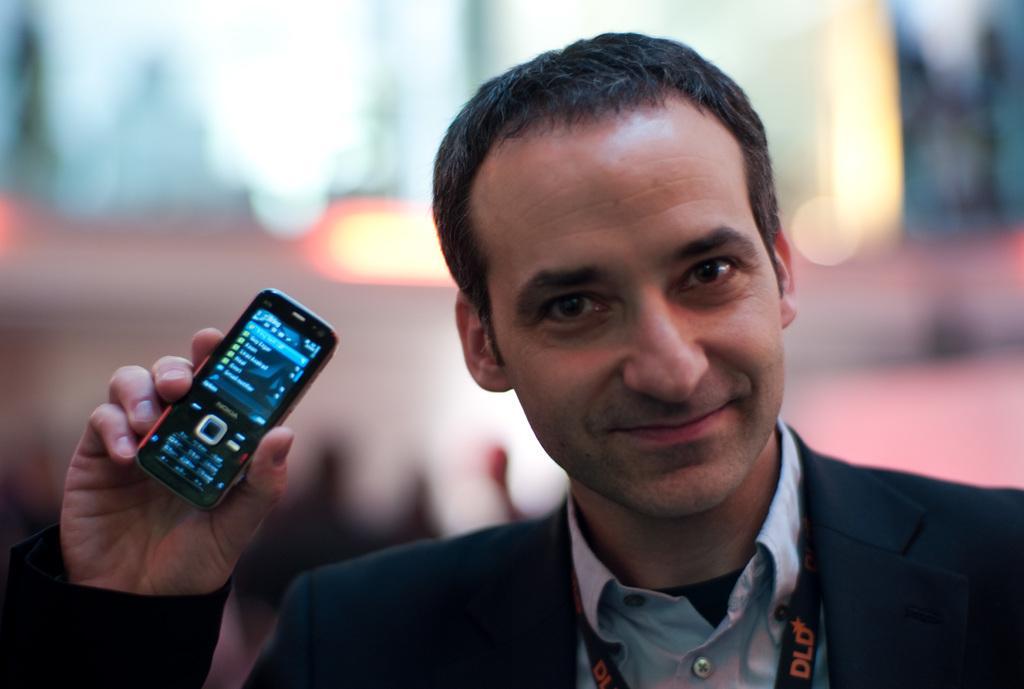How would you summarize this image in a sentence or two? In this picture we can see man wore blazer, tag, holding mobile in his hand and he is smiling and in the background we can see some lights and it is blurry. 